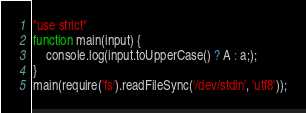Convert code to text. <code><loc_0><loc_0><loc_500><loc_500><_JavaScript_>"use strict"
function main(input) {
    console.log(input.toUpperCase() ? A : a;);
}
main(require('fs').readFileSync('/dev/stdin', 'utf8'));</code> 